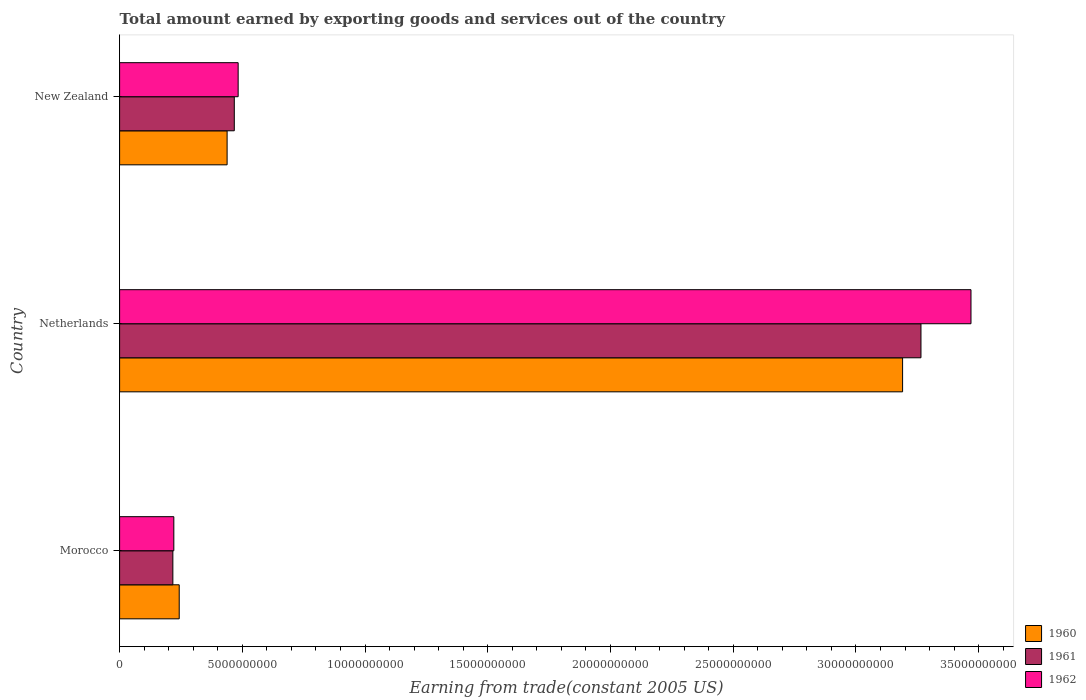Are the number of bars on each tick of the Y-axis equal?
Your response must be concise. Yes. How many bars are there on the 2nd tick from the top?
Provide a succinct answer. 3. What is the label of the 3rd group of bars from the top?
Your answer should be very brief. Morocco. What is the total amount earned by exporting goods and services in 1961 in Morocco?
Provide a succinct answer. 2.17e+09. Across all countries, what is the maximum total amount earned by exporting goods and services in 1962?
Your response must be concise. 3.47e+1. Across all countries, what is the minimum total amount earned by exporting goods and services in 1962?
Provide a short and direct response. 2.21e+09. In which country was the total amount earned by exporting goods and services in 1960 maximum?
Your answer should be compact. Netherlands. In which country was the total amount earned by exporting goods and services in 1960 minimum?
Your answer should be very brief. Morocco. What is the total total amount earned by exporting goods and services in 1961 in the graph?
Make the answer very short. 3.95e+1. What is the difference between the total amount earned by exporting goods and services in 1961 in Morocco and that in New Zealand?
Your response must be concise. -2.50e+09. What is the difference between the total amount earned by exporting goods and services in 1961 in Netherlands and the total amount earned by exporting goods and services in 1960 in Morocco?
Your answer should be compact. 3.02e+1. What is the average total amount earned by exporting goods and services in 1961 per country?
Offer a very short reply. 1.32e+1. What is the difference between the total amount earned by exporting goods and services in 1960 and total amount earned by exporting goods and services in 1961 in New Zealand?
Your answer should be compact. -2.93e+08. What is the ratio of the total amount earned by exporting goods and services in 1960 in Morocco to that in Netherlands?
Ensure brevity in your answer.  0.08. Is the total amount earned by exporting goods and services in 1960 in Morocco less than that in Netherlands?
Your answer should be compact. Yes. Is the difference between the total amount earned by exporting goods and services in 1960 in Morocco and New Zealand greater than the difference between the total amount earned by exporting goods and services in 1961 in Morocco and New Zealand?
Your response must be concise. Yes. What is the difference between the highest and the second highest total amount earned by exporting goods and services in 1961?
Provide a succinct answer. 2.80e+1. What is the difference between the highest and the lowest total amount earned by exporting goods and services in 1962?
Your answer should be very brief. 3.25e+1. Is the sum of the total amount earned by exporting goods and services in 1961 in Morocco and Netherlands greater than the maximum total amount earned by exporting goods and services in 1962 across all countries?
Offer a very short reply. Yes. Is it the case that in every country, the sum of the total amount earned by exporting goods and services in 1960 and total amount earned by exporting goods and services in 1961 is greater than the total amount earned by exporting goods and services in 1962?
Ensure brevity in your answer.  Yes. How many bars are there?
Offer a very short reply. 9. Does the graph contain grids?
Make the answer very short. No. Where does the legend appear in the graph?
Provide a short and direct response. Bottom right. How are the legend labels stacked?
Ensure brevity in your answer.  Vertical. What is the title of the graph?
Offer a terse response. Total amount earned by exporting goods and services out of the country. Does "1961" appear as one of the legend labels in the graph?
Give a very brief answer. Yes. What is the label or title of the X-axis?
Offer a very short reply. Earning from trade(constant 2005 US). What is the Earning from trade(constant 2005 US) of 1960 in Morocco?
Give a very brief answer. 2.43e+09. What is the Earning from trade(constant 2005 US) in 1961 in Morocco?
Provide a succinct answer. 2.17e+09. What is the Earning from trade(constant 2005 US) in 1962 in Morocco?
Provide a short and direct response. 2.21e+09. What is the Earning from trade(constant 2005 US) in 1960 in Netherlands?
Your answer should be very brief. 3.19e+1. What is the Earning from trade(constant 2005 US) of 1961 in Netherlands?
Make the answer very short. 3.26e+1. What is the Earning from trade(constant 2005 US) in 1962 in Netherlands?
Ensure brevity in your answer.  3.47e+1. What is the Earning from trade(constant 2005 US) in 1960 in New Zealand?
Make the answer very short. 4.38e+09. What is the Earning from trade(constant 2005 US) in 1961 in New Zealand?
Make the answer very short. 4.67e+09. What is the Earning from trade(constant 2005 US) in 1962 in New Zealand?
Provide a short and direct response. 4.83e+09. Across all countries, what is the maximum Earning from trade(constant 2005 US) in 1960?
Give a very brief answer. 3.19e+1. Across all countries, what is the maximum Earning from trade(constant 2005 US) of 1961?
Provide a short and direct response. 3.26e+1. Across all countries, what is the maximum Earning from trade(constant 2005 US) in 1962?
Offer a terse response. 3.47e+1. Across all countries, what is the minimum Earning from trade(constant 2005 US) of 1960?
Offer a very short reply. 2.43e+09. Across all countries, what is the minimum Earning from trade(constant 2005 US) of 1961?
Make the answer very short. 2.17e+09. Across all countries, what is the minimum Earning from trade(constant 2005 US) in 1962?
Your answer should be compact. 2.21e+09. What is the total Earning from trade(constant 2005 US) of 1960 in the graph?
Your answer should be compact. 3.87e+1. What is the total Earning from trade(constant 2005 US) in 1961 in the graph?
Keep it short and to the point. 3.95e+1. What is the total Earning from trade(constant 2005 US) of 1962 in the graph?
Your answer should be very brief. 4.17e+1. What is the difference between the Earning from trade(constant 2005 US) of 1960 in Morocco and that in Netherlands?
Your response must be concise. -2.95e+1. What is the difference between the Earning from trade(constant 2005 US) in 1961 in Morocco and that in Netherlands?
Provide a succinct answer. -3.05e+1. What is the difference between the Earning from trade(constant 2005 US) of 1962 in Morocco and that in Netherlands?
Your response must be concise. -3.25e+1. What is the difference between the Earning from trade(constant 2005 US) in 1960 in Morocco and that in New Zealand?
Your response must be concise. -1.95e+09. What is the difference between the Earning from trade(constant 2005 US) of 1961 in Morocco and that in New Zealand?
Keep it short and to the point. -2.50e+09. What is the difference between the Earning from trade(constant 2005 US) in 1962 in Morocco and that in New Zealand?
Your response must be concise. -2.62e+09. What is the difference between the Earning from trade(constant 2005 US) in 1960 in Netherlands and that in New Zealand?
Keep it short and to the point. 2.75e+1. What is the difference between the Earning from trade(constant 2005 US) in 1961 in Netherlands and that in New Zealand?
Your answer should be compact. 2.80e+1. What is the difference between the Earning from trade(constant 2005 US) of 1962 in Netherlands and that in New Zealand?
Your response must be concise. 2.99e+1. What is the difference between the Earning from trade(constant 2005 US) in 1960 in Morocco and the Earning from trade(constant 2005 US) in 1961 in Netherlands?
Offer a very short reply. -3.02e+1. What is the difference between the Earning from trade(constant 2005 US) in 1960 in Morocco and the Earning from trade(constant 2005 US) in 1962 in Netherlands?
Give a very brief answer. -3.23e+1. What is the difference between the Earning from trade(constant 2005 US) in 1961 in Morocco and the Earning from trade(constant 2005 US) in 1962 in Netherlands?
Your answer should be very brief. -3.25e+1. What is the difference between the Earning from trade(constant 2005 US) of 1960 in Morocco and the Earning from trade(constant 2005 US) of 1961 in New Zealand?
Your response must be concise. -2.24e+09. What is the difference between the Earning from trade(constant 2005 US) in 1960 in Morocco and the Earning from trade(constant 2005 US) in 1962 in New Zealand?
Your answer should be very brief. -2.40e+09. What is the difference between the Earning from trade(constant 2005 US) in 1961 in Morocco and the Earning from trade(constant 2005 US) in 1962 in New Zealand?
Provide a short and direct response. -2.66e+09. What is the difference between the Earning from trade(constant 2005 US) in 1960 in Netherlands and the Earning from trade(constant 2005 US) in 1961 in New Zealand?
Provide a short and direct response. 2.72e+1. What is the difference between the Earning from trade(constant 2005 US) of 1960 in Netherlands and the Earning from trade(constant 2005 US) of 1962 in New Zealand?
Offer a terse response. 2.71e+1. What is the difference between the Earning from trade(constant 2005 US) of 1961 in Netherlands and the Earning from trade(constant 2005 US) of 1962 in New Zealand?
Make the answer very short. 2.78e+1. What is the average Earning from trade(constant 2005 US) in 1960 per country?
Your answer should be compact. 1.29e+1. What is the average Earning from trade(constant 2005 US) in 1961 per country?
Provide a short and direct response. 1.32e+1. What is the average Earning from trade(constant 2005 US) in 1962 per country?
Make the answer very short. 1.39e+1. What is the difference between the Earning from trade(constant 2005 US) of 1960 and Earning from trade(constant 2005 US) of 1961 in Morocco?
Make the answer very short. 2.59e+08. What is the difference between the Earning from trade(constant 2005 US) in 1960 and Earning from trade(constant 2005 US) in 1962 in Morocco?
Your answer should be very brief. 2.19e+08. What is the difference between the Earning from trade(constant 2005 US) in 1961 and Earning from trade(constant 2005 US) in 1962 in Morocco?
Offer a terse response. -3.93e+07. What is the difference between the Earning from trade(constant 2005 US) of 1960 and Earning from trade(constant 2005 US) of 1961 in Netherlands?
Provide a succinct answer. -7.48e+08. What is the difference between the Earning from trade(constant 2005 US) of 1960 and Earning from trade(constant 2005 US) of 1962 in Netherlands?
Provide a succinct answer. -2.79e+09. What is the difference between the Earning from trade(constant 2005 US) in 1961 and Earning from trade(constant 2005 US) in 1962 in Netherlands?
Offer a terse response. -2.04e+09. What is the difference between the Earning from trade(constant 2005 US) in 1960 and Earning from trade(constant 2005 US) in 1961 in New Zealand?
Provide a short and direct response. -2.93e+08. What is the difference between the Earning from trade(constant 2005 US) in 1960 and Earning from trade(constant 2005 US) in 1962 in New Zealand?
Provide a short and direct response. -4.50e+08. What is the difference between the Earning from trade(constant 2005 US) in 1961 and Earning from trade(constant 2005 US) in 1962 in New Zealand?
Ensure brevity in your answer.  -1.57e+08. What is the ratio of the Earning from trade(constant 2005 US) in 1960 in Morocco to that in Netherlands?
Make the answer very short. 0.08. What is the ratio of the Earning from trade(constant 2005 US) in 1961 in Morocco to that in Netherlands?
Provide a succinct answer. 0.07. What is the ratio of the Earning from trade(constant 2005 US) of 1962 in Morocco to that in Netherlands?
Your answer should be compact. 0.06. What is the ratio of the Earning from trade(constant 2005 US) of 1960 in Morocco to that in New Zealand?
Keep it short and to the point. 0.55. What is the ratio of the Earning from trade(constant 2005 US) in 1961 in Morocco to that in New Zealand?
Give a very brief answer. 0.46. What is the ratio of the Earning from trade(constant 2005 US) of 1962 in Morocco to that in New Zealand?
Your answer should be very brief. 0.46. What is the ratio of the Earning from trade(constant 2005 US) in 1960 in Netherlands to that in New Zealand?
Make the answer very short. 7.28. What is the ratio of the Earning from trade(constant 2005 US) of 1961 in Netherlands to that in New Zealand?
Give a very brief answer. 6.99. What is the ratio of the Earning from trade(constant 2005 US) of 1962 in Netherlands to that in New Zealand?
Offer a very short reply. 7.18. What is the difference between the highest and the second highest Earning from trade(constant 2005 US) in 1960?
Your answer should be compact. 2.75e+1. What is the difference between the highest and the second highest Earning from trade(constant 2005 US) of 1961?
Your response must be concise. 2.80e+1. What is the difference between the highest and the second highest Earning from trade(constant 2005 US) of 1962?
Provide a succinct answer. 2.99e+1. What is the difference between the highest and the lowest Earning from trade(constant 2005 US) in 1960?
Provide a succinct answer. 2.95e+1. What is the difference between the highest and the lowest Earning from trade(constant 2005 US) of 1961?
Give a very brief answer. 3.05e+1. What is the difference between the highest and the lowest Earning from trade(constant 2005 US) in 1962?
Provide a succinct answer. 3.25e+1. 